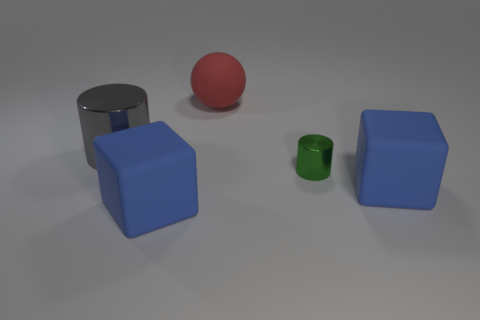What guesses can we make about the weight of these objects based on their size and material? If we assume that the objects are made from standard materials, the gray cylinder might be the heaviest due to its metallic appearance and volume. The blue cubes are likely lighter, suggesting a material like plastic or wood. The red sphere and green cylinder are smaller and would be lighter in weight if made from similar materials as the blue cubes. 